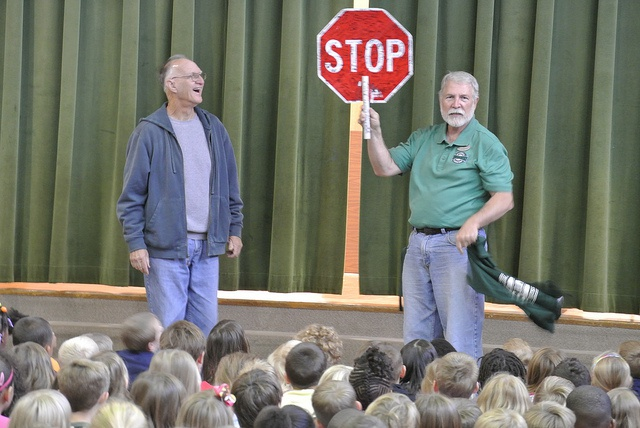Describe the objects in this image and their specific colors. I can see people in gray, darkgray, and lightgray tones, people in gray, lavender, and darkgray tones, people in gray, teal, and darkgray tones, stop sign in gray, brown, and lavender tones, and people in gray, ivory, and black tones in this image. 